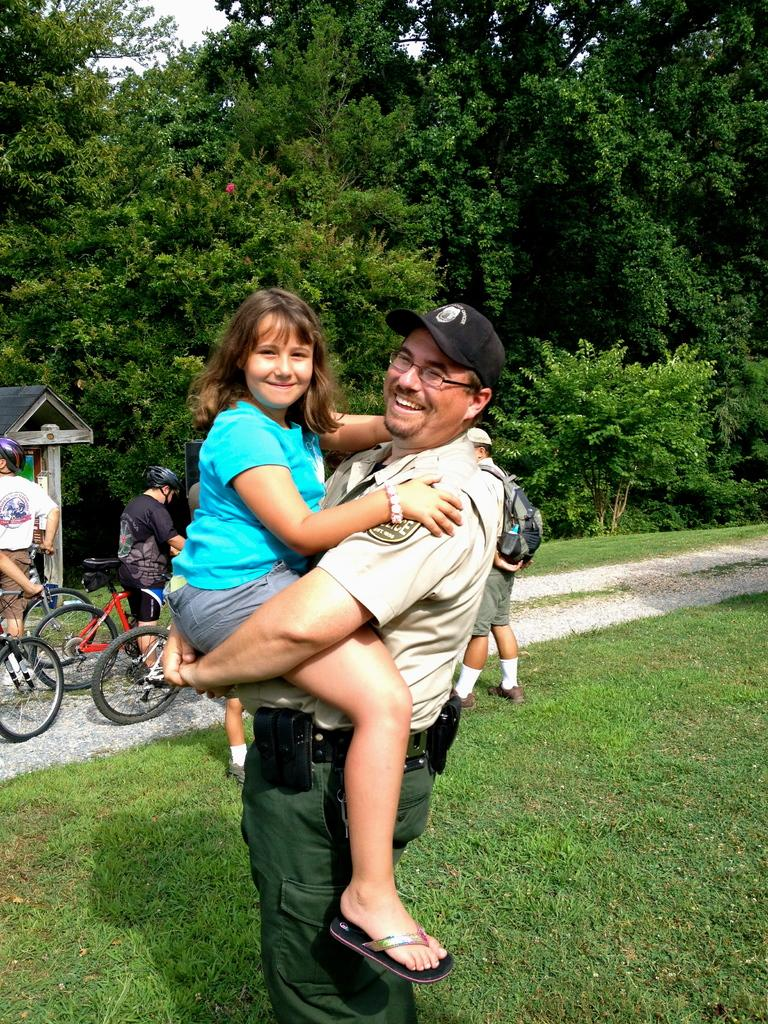What is the man in the image doing with the girl? The man is holding the girl in the image. What activity are some people engaged in within the image? There are people riding a bicycle in the image. What type of terrain is visible in the image? There is grass on the ground in the image. What can be seen in the distance in the image? There are trees in the background of the image. What type of coil is being used to power the invention in the image? There is no coil or invention present in the image. What architectural feature can be seen in the background of the image? There are no specific architectural features mentioned in the provided facts, only trees in the background. 